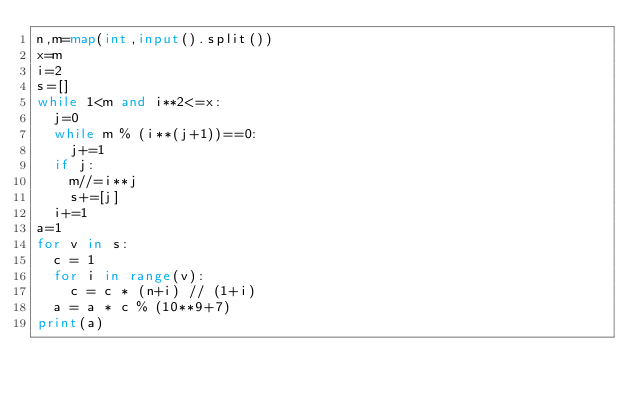<code> <loc_0><loc_0><loc_500><loc_500><_Python_>n,m=map(int,input().split())
x=m
i=2
s=[]
while 1<m and i**2<=x:
  j=0
  while m % (i**(j+1))==0:
    j+=1
  if j:
    m//=i**j
    s+=[j]
  i+=1
a=1
for v in s:
  c = 1
  for i in range(v):
    c = c * (n+i) // (1+i)
  a = a * c % (10**9+7)
print(a)
</code> 